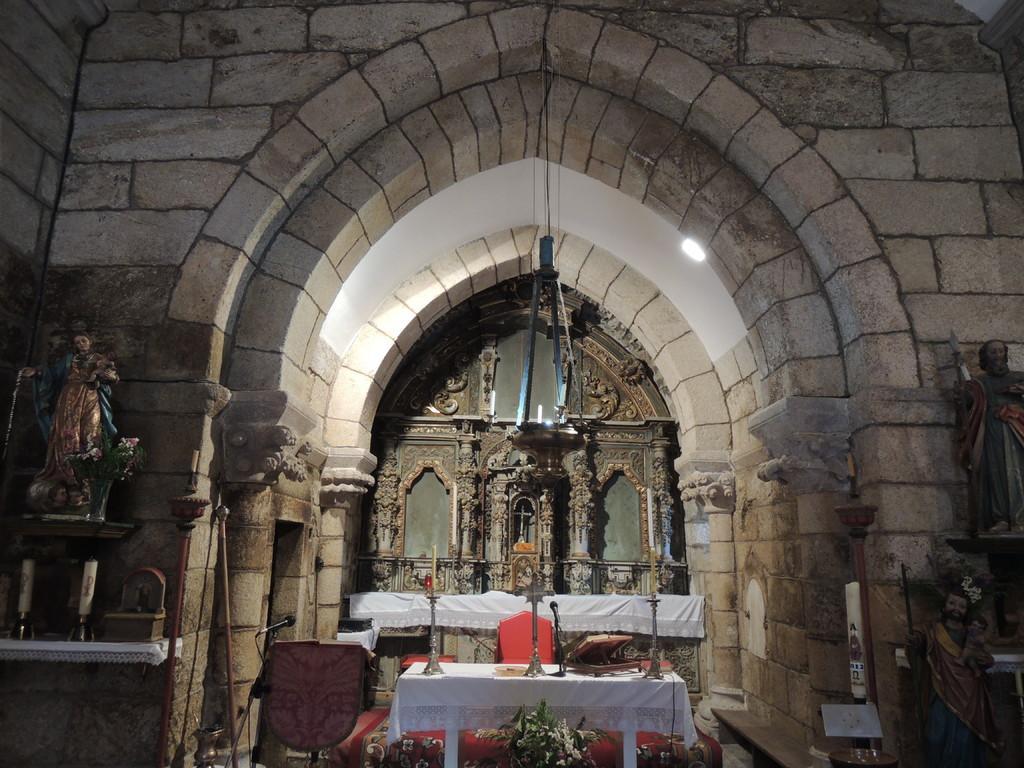Could you give a brief overview of what you see in this image? In the picture I can see the cathedral construction. I can see the statues of the goddess on the left side and the right side. I can see the table which is covered with white color cloth and there are candle stands on the table. I can see the flowers at the bottom of the picture. I can see the microphone with stand on the bottom left side. 